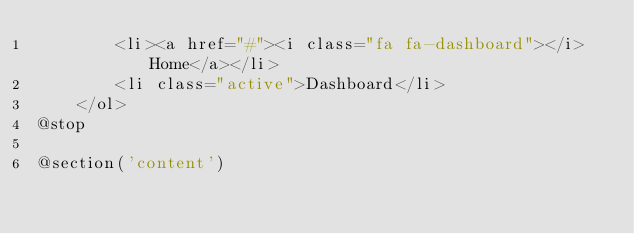Convert code to text. <code><loc_0><loc_0><loc_500><loc_500><_PHP_>        <li><a href="#"><i class="fa fa-dashboard"></i> Home</a></li>
        <li class="active">Dashboard</li>
    </ol>
@stop

@section('content')</code> 